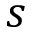Convert formula to latex. <formula><loc_0><loc_0><loc_500><loc_500>s</formula> 